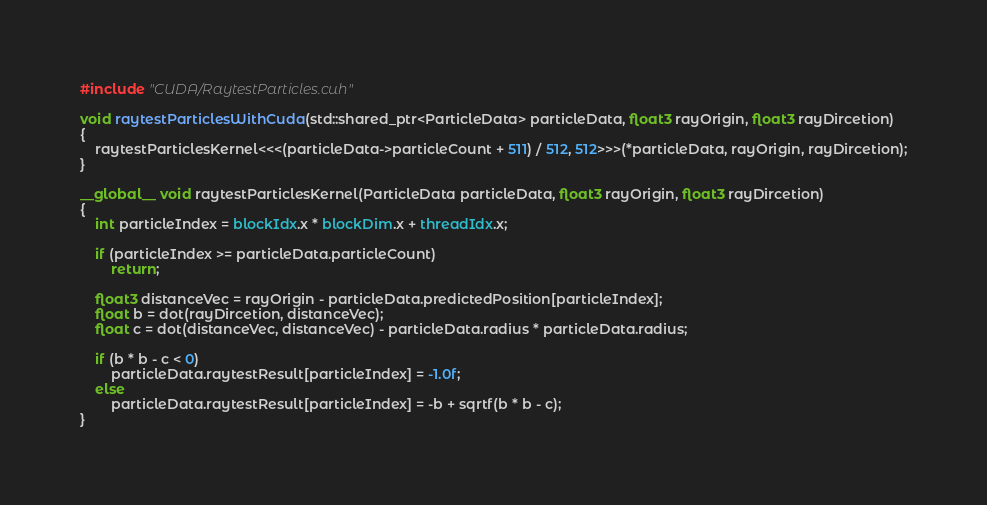Convert code to text. <code><loc_0><loc_0><loc_500><loc_500><_Cuda_>#include "CUDA/RaytestParticles.cuh"

void raytestParticlesWithCuda(std::shared_ptr<ParticleData> particleData, float3 rayOrigin, float3 rayDircetion)
{
	raytestParticlesKernel<<<(particleData->particleCount + 511) / 512, 512>>>(*particleData, rayOrigin, rayDircetion);
}

__global__ void raytestParticlesKernel(ParticleData particleData, float3 rayOrigin, float3 rayDircetion)
{
	int particleIndex = blockIdx.x * blockDim.x + threadIdx.x;

	if (particleIndex >= particleData.particleCount)
		return;

	float3 distanceVec = rayOrigin - particleData.predictedPosition[particleIndex];
	float b = dot(rayDircetion, distanceVec);
	float c = dot(distanceVec, distanceVec) - particleData.radius * particleData.radius;

	if (b * b - c < 0)
		particleData.raytestResult[particleIndex] = -1.0f;
	else
		particleData.raytestResult[particleIndex] = -b + sqrtf(b * b - c);
}</code> 